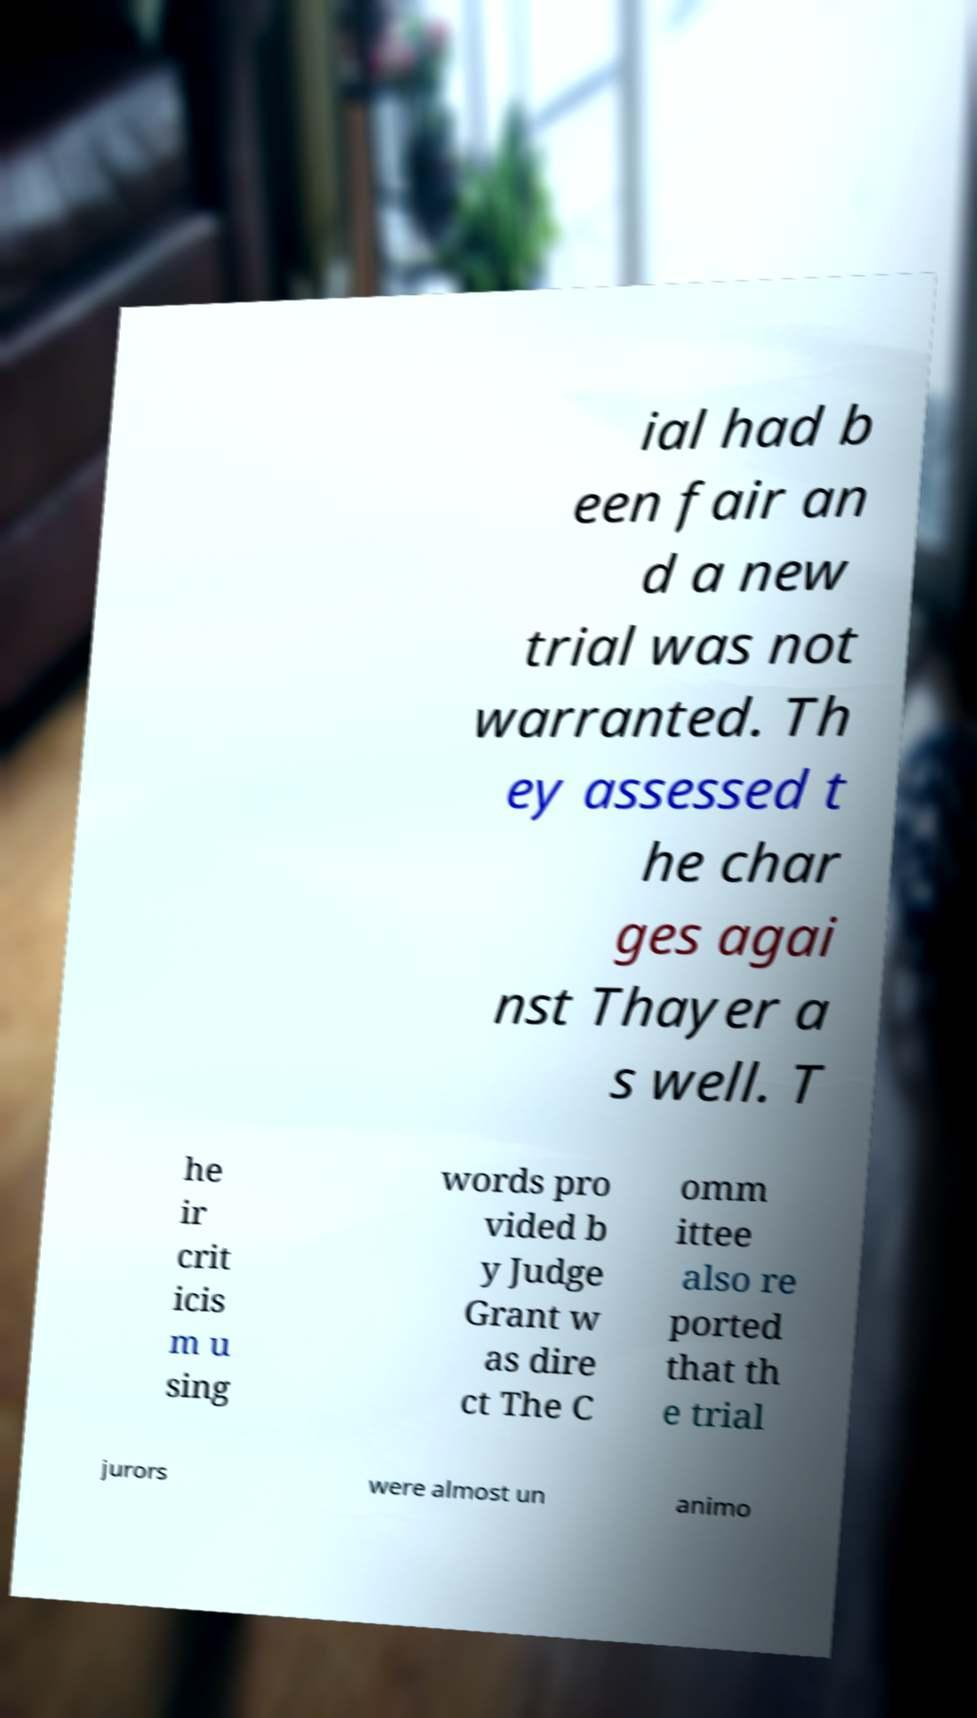Could you assist in decoding the text presented in this image and type it out clearly? ial had b een fair an d a new trial was not warranted. Th ey assessed t he char ges agai nst Thayer a s well. T he ir crit icis m u sing words pro vided b y Judge Grant w as dire ct The C omm ittee also re ported that th e trial jurors were almost un animo 